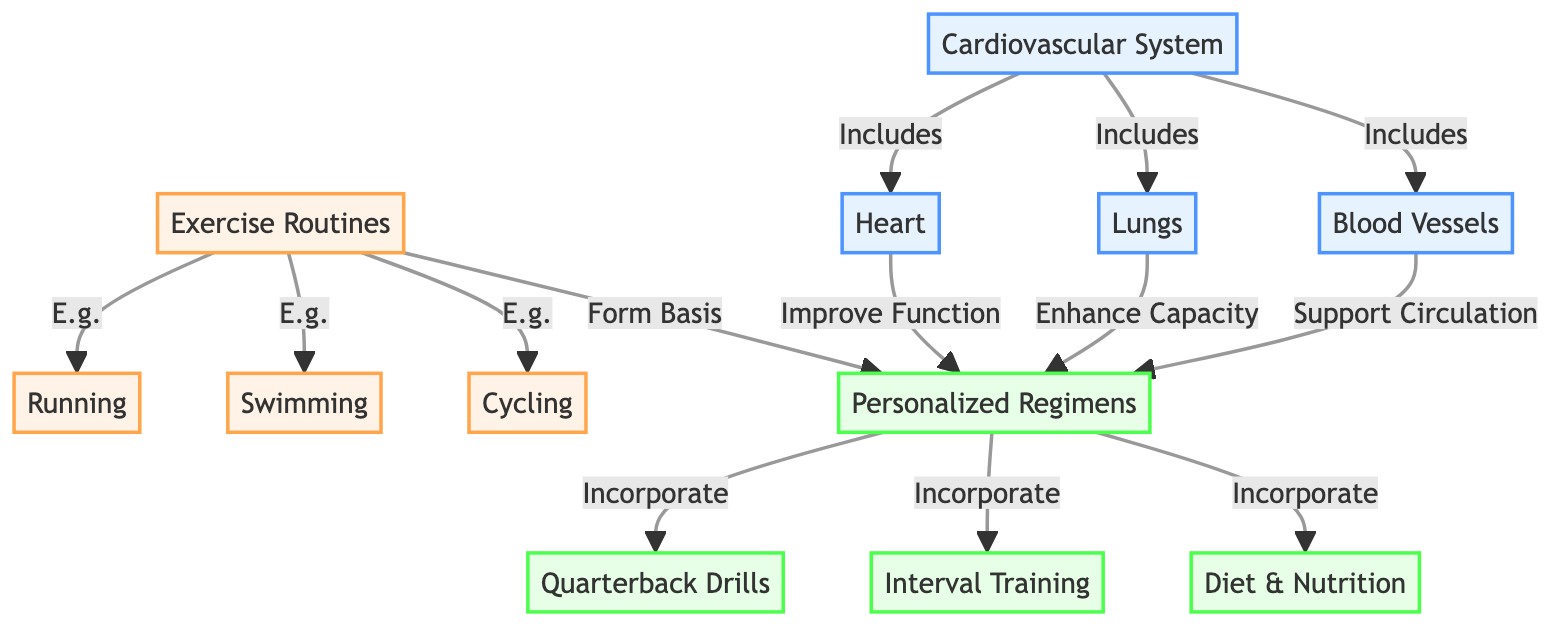What are the components of the cardiovascular system? The diagram lists three components connected to the "Cardiovascular System": "Heart," "Lungs," and "Blood Vessels."
Answer: Heart, Lungs, Blood Vessels How many exercise routines are highlighted in the diagram? The diagram contains three exercise routines branching from "Exercise Routines": "Running," "Swimming," and "Cycling." By counting these nodes, we find there are three.
Answer: 3 What is the main benefit of personalized regimens according to the diagram? The diagram suggests that personalized regimens are linked to improving heart function, enhancing lung capacity, and supporting blood vessel circulation. The main benefit can be categorized as improving performance.
Answer: Improving performance Which exercise is not listed as a routine in the diagram? The diagram mentions "Running," "Swimming," and "Cycling" but does not include exercises like "Weightlifting" or "Yoga." Therefore, any of those unmentioned activities are correct answers.
Answer: Weightlifting (or Yoga, etc.) What exercises are incorporated into personalized regimens? The diagram shows that "Personalized Regimens" incorporate "Quarterback Drills," "Interval Training," and "Diet & Nutrition." Therefore, these activities represent a comprehensive approach to conditioning.
Answer: Quarterback Drills, Interval Training, Diet & Nutrition Which part of the cardiovascular system enhances lung capacity? The diagram indicates that the "Lungs" component of the cardiovascular system is explicitly labeled as responsible for enhancing capacity, confirming their important role in cardiovascular conditioning for athletes.
Answer: Lungs How many nodes represent exercise routines within the diagram? Counting the nodes branching from "Exercise Routines," there are three outlined: "Running," "Swimming," and "Cycling." Thus, the total is three.
Answer: 3 What supports circulation in the context of personalized regimens? The diagram connects "Blood Vessels" to "Personalized Regimens" indicating that blood vessels play a supportive role in circulation, a critical aspect of cardiovascular health and performance enhancement.
Answer: Blood Vessels 